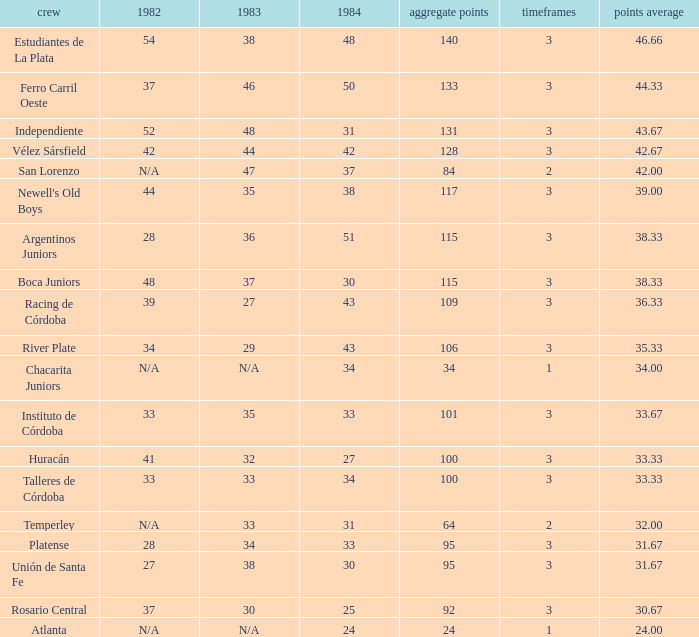What is the points total for the team with points average more than 34, 1984 score more than 37 and N/A in 1982? 0.0. 